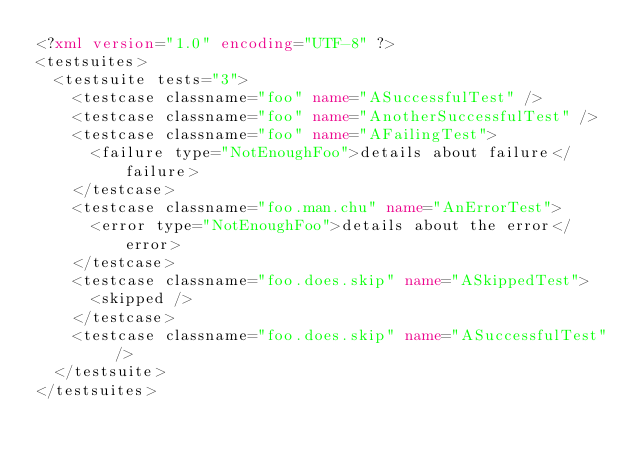Convert code to text. <code><loc_0><loc_0><loc_500><loc_500><_XML_><?xml version="1.0" encoding="UTF-8" ?>
<testsuites>
  <testsuite tests="3">
    <testcase classname="foo" name="ASuccessfulTest" />
    <testcase classname="foo" name="AnotherSuccessfulTest" />
    <testcase classname="foo" name="AFailingTest">
      <failure type="NotEnoughFoo">details about failure</failure>
    </testcase>
    <testcase classname="foo.man.chu" name="AnErrorTest">
      <error type="NotEnoughFoo">details about the error</error>
    </testcase>
    <testcase classname="foo.does.skip" name="ASkippedTest">
      <skipped />
    </testcase>
    <testcase classname="foo.does.skip" name="ASuccessfulTest" />
  </testsuite>
</testsuites></code> 